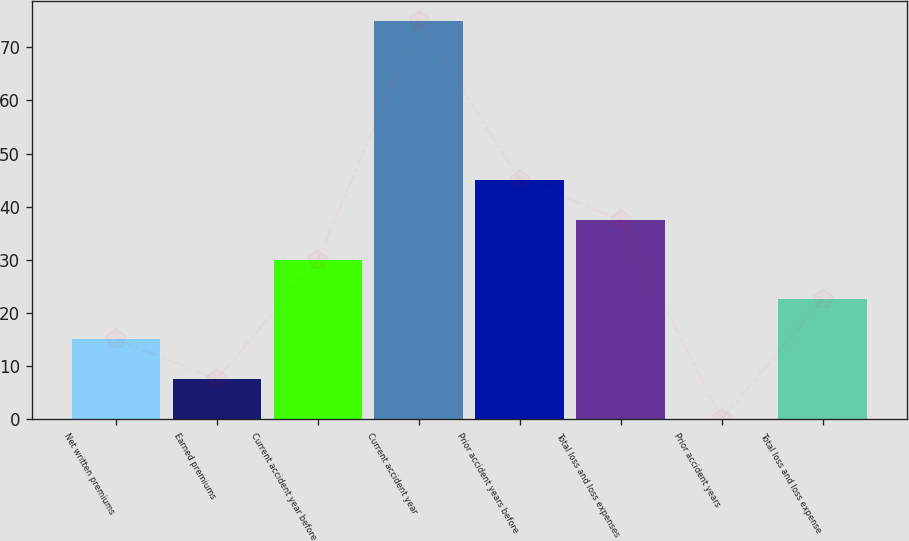Convert chart to OTSL. <chart><loc_0><loc_0><loc_500><loc_500><bar_chart><fcel>Net written premiums<fcel>Earned premiums<fcel>Current accident year before<fcel>Current accident year<fcel>Prior accident years before<fcel>Total loss and loss expenses<fcel>Prior accident years<fcel>Total loss and loss expense<nl><fcel>15.08<fcel>7.59<fcel>30.06<fcel>75<fcel>45.04<fcel>37.55<fcel>0.1<fcel>22.57<nl></chart> 